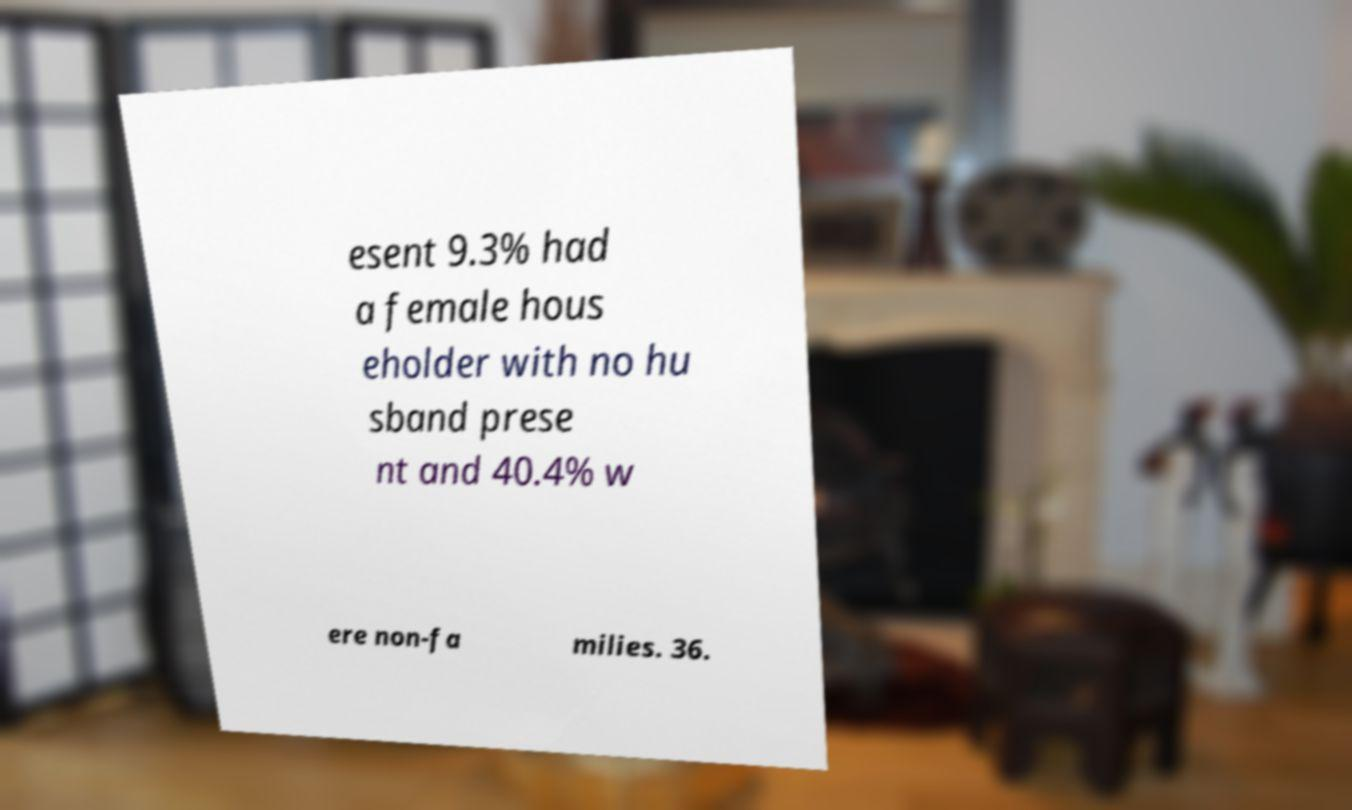What messages or text are displayed in this image? I need them in a readable, typed format. esent 9.3% had a female hous eholder with no hu sband prese nt and 40.4% w ere non-fa milies. 36. 